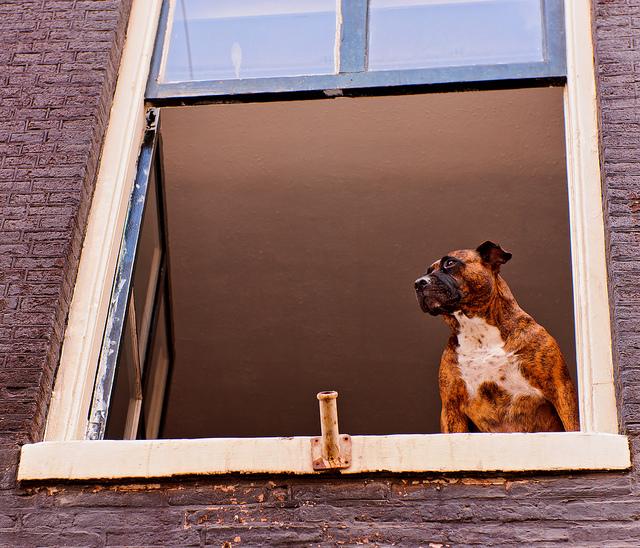Where is the dog sitting?
Give a very brief answer. Window. What is the building made out of?
Write a very short answer. Brick. Does the window need to be repainted?
Short answer required. Yes. Is the dog wearing a collar?
Be succinct. No. 